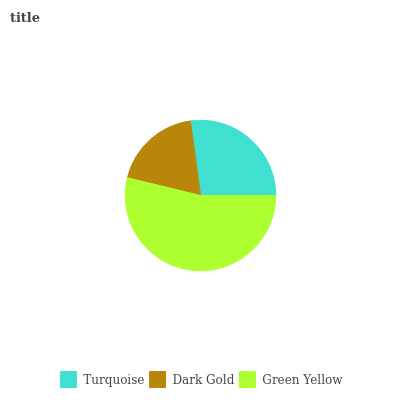Is Dark Gold the minimum?
Answer yes or no. Yes. Is Green Yellow the maximum?
Answer yes or no. Yes. Is Green Yellow the minimum?
Answer yes or no. No. Is Dark Gold the maximum?
Answer yes or no. No. Is Green Yellow greater than Dark Gold?
Answer yes or no. Yes. Is Dark Gold less than Green Yellow?
Answer yes or no. Yes. Is Dark Gold greater than Green Yellow?
Answer yes or no. No. Is Green Yellow less than Dark Gold?
Answer yes or no. No. Is Turquoise the high median?
Answer yes or no. Yes. Is Turquoise the low median?
Answer yes or no. Yes. Is Dark Gold the high median?
Answer yes or no. No. Is Green Yellow the low median?
Answer yes or no. No. 